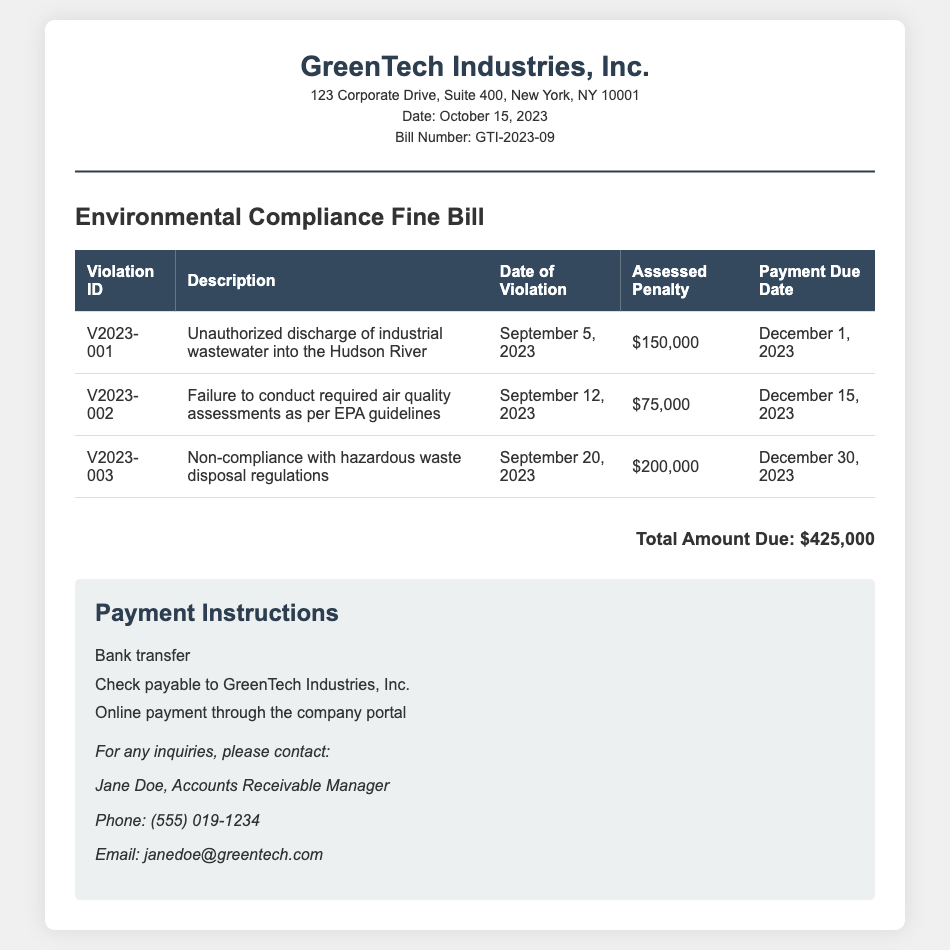What is the violation ID for the unauthorized discharge? The violation ID corresponding to the unauthorized discharge is mentioned in the table as V2023-001.
Answer: V2023-001 What is the assessed penalty for non-compliance with hazardous waste disposal regulations? The assessed penalty for non-compliance with hazardous waste disposal is identified in the table as $200,000.
Answer: $200,000 What is the payment due date for the air quality assessments violation? The payment due date for the violation related to air quality assessments as stated in the document is December 15, 2023.
Answer: December 15, 2023 How much is the total amount due? The total amount due is the sum of all assessed penalties listed in the document, which is $425,000.
Answer: $425,000 When did the unauthorized discharge of industrial wastewater occur? The date of the unauthorized discharge is specified in the document as September 5, 2023.
Answer: September 5, 2023 What methods of payment are available in this bill? The document lists three methods of payment: bank transfer, check payable to GreenTech Industries, Inc., and online payment through the company portal.
Answer: Bank transfer, check, online payment Who is the Accounts Receivable Manager? The name of the Accounts Receivable Manager as provided in the document is Jane Doe.
Answer: Jane Doe What date was this bill issued? The date the bill was issued is clearly mentioned in the document as October 15, 2023.
Answer: October 15, 2023 What is the main purpose of this document? The main purpose of this document is to issue an environmental compliance fine bill detailing violations and penalties to GreenTech Industries, Inc.
Answer: Environmental Compliance Fine Bill 